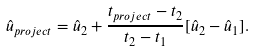Convert formula to latex. <formula><loc_0><loc_0><loc_500><loc_500>\hat { u } _ { p r o j e c t } = \hat { u } _ { 2 } + \frac { t _ { p r o j e c t } - t _ { 2 } } { t _ { 2 } - t _ { 1 } } [ \hat { u } _ { 2 } - \hat { u } _ { 1 } ] .</formula> 